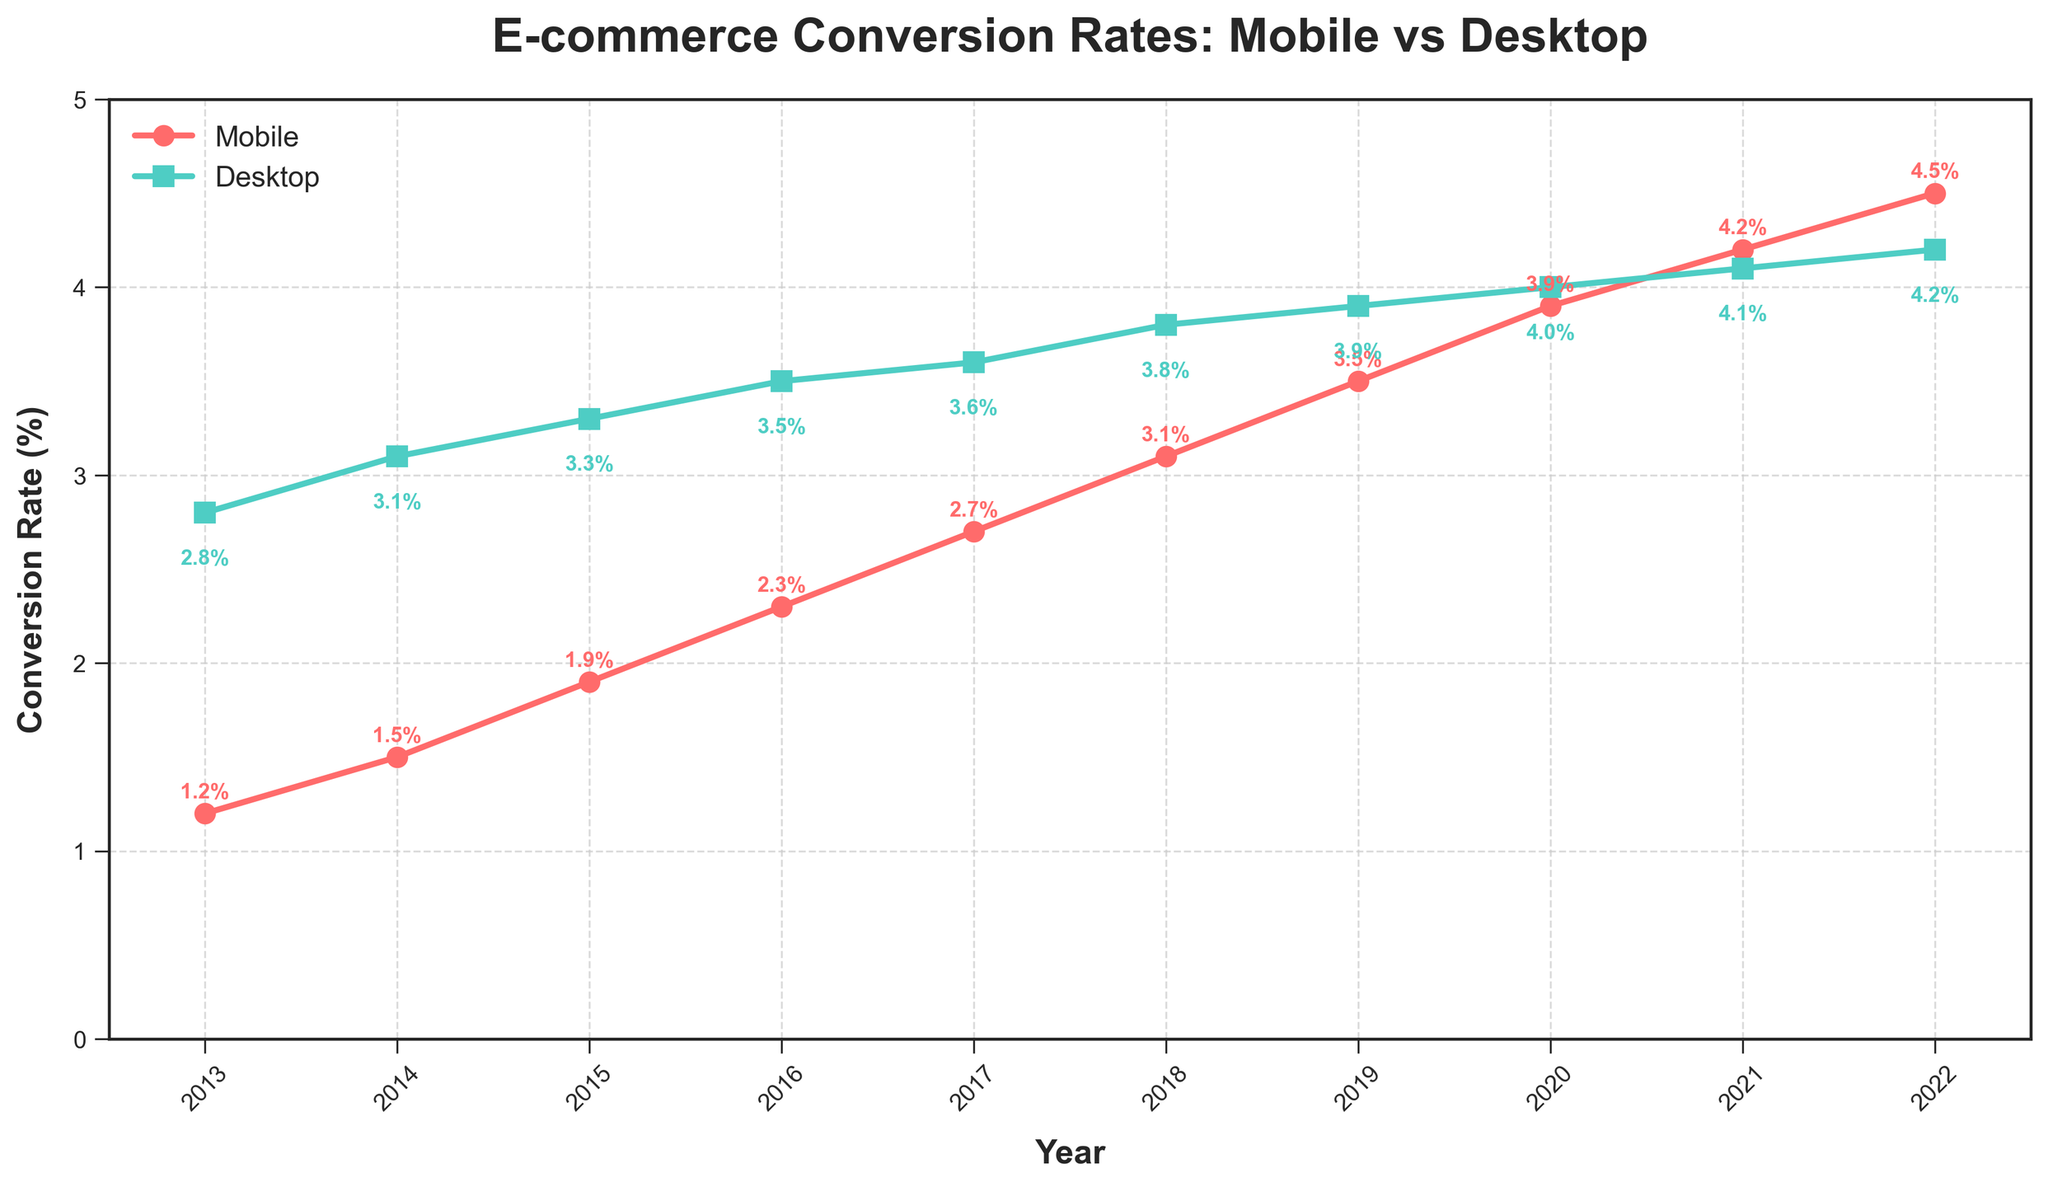What was the conversion rate difference between mobile and desktop shoppers in 2013? To find the conversion rate difference between mobile and desktop shoppers in 2013, subtract the mobile conversion rate from the desktop conversion rate. In 2013, the mobile conversion rate was 1.2% and the desktop conversion rate was 2.8%. So, 2.8% - 1.2% = 1.6%.
Answer: 1.6% In which year did mobile shoppers have a higher conversion rate increase compared to the previous year? To determine which year saw the highest increase in mobile conversion rates, compare the year-by-year increase. From 2013 to 2022, the increases were 0.3%, 0.4%, 0.4%, 0.4%, 0.4%, 0.4%, 0.4%, 0.3%, 0.3%, respectively. The highest increase was 0.4%, which happened in multiple consecutive years from 2014 to 2018.
Answer: 2014 - 2018 By how much did the mobile conversion rate grow from 2013 to 2022? To find the total growth in mobile conversion rates from 2013 to 2022, subtract the conversion rate in 2013 from the rate in 2022. In 2013, it was 1.2%, and in 2022, it was 4.5%. So, 4.5% - 1.2% = 3.3%.
Answer: 3.3% Which conversion rate, mobile or desktop, had the smallest difference between 2013 and 2022? Calculate the differences in conversion rates from 2013 to 2022 for both mobile and desktop. For mobile: 4.5% - 1.2% = 3.3%. For desktop: 4.2% - 2.8% = 1.4%. The desktop conversion rate had the smaller difference.
Answer: Desktop In which year did the mobile conversion rate surpass 2%? Identify the first year where the mobile conversion rate was greater than 2%. In 2016, the mobile conversion rate was 2.3%, which is the first year it surpasses 2%.
Answer: 2016 By how much did the desktop conversion rate increase from 2014 to 2020? Calculate the increase in desktop conversion rates from 2014 to 2020. In 2014, it was 3.1%, and in 2020, it was 4.0%. So, 4.0% - 3.1% = 0.9%.
Answer: 0.9% Which year had the smallest gap between mobile and desktop conversion rates? Find the year where the difference between mobile and desktop conversion rates was the smallest. In 2022, the gap is smallest at 4.2% - 4.5% = 0.3%.
Answer: 2022 How much did both mobile and desktop conversion rates grow on average annually? To find the annual growth for both rates, calculate the total growth from 2013 to 2022 and then divide by the number of years. For mobile: (4.5% - 1.2%) / 9 ≈ 0.367% per year. For desktop: (4.2% - 2.8%) / 9 ≈ 0.156% per year.
Answer: 0.367% (mobile), 0.156% (desktop) Which year had the highest desktop conversion rate? Identify the year with the highest value for desktop conversion rates. In 2022, the desktop conversion rate was highest at 4.2%.
Answer: 2022 